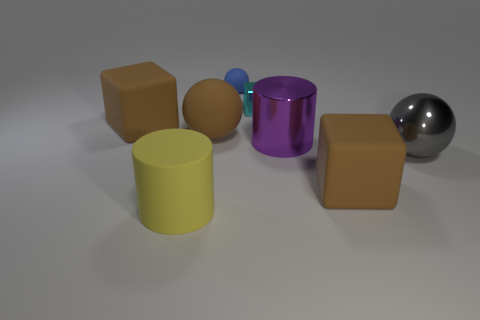Is the number of purple objects greater than the number of large things?
Give a very brief answer. No. Is there a shiny cube that has the same size as the blue sphere?
Your answer should be very brief. Yes. What number of objects are either cylinders that are right of the small rubber object or brown matte objects that are behind the big purple metal cylinder?
Make the answer very short. 3. What is the color of the sphere that is behind the big brown block that is behind the gray shiny object?
Your response must be concise. Blue. What is the color of the block that is made of the same material as the purple thing?
Your answer should be very brief. Cyan. What number of rubber objects are the same color as the large matte sphere?
Give a very brief answer. 2. How many objects are purple metal objects or big metal balls?
Keep it short and to the point. 2. What is the shape of the purple metallic thing that is the same size as the yellow thing?
Provide a short and direct response. Cylinder. How many cylinders are both in front of the big gray shiny ball and right of the big yellow rubber cylinder?
Your answer should be compact. 0. What is the material of the brown block that is on the right side of the purple metal cylinder?
Make the answer very short. Rubber. 